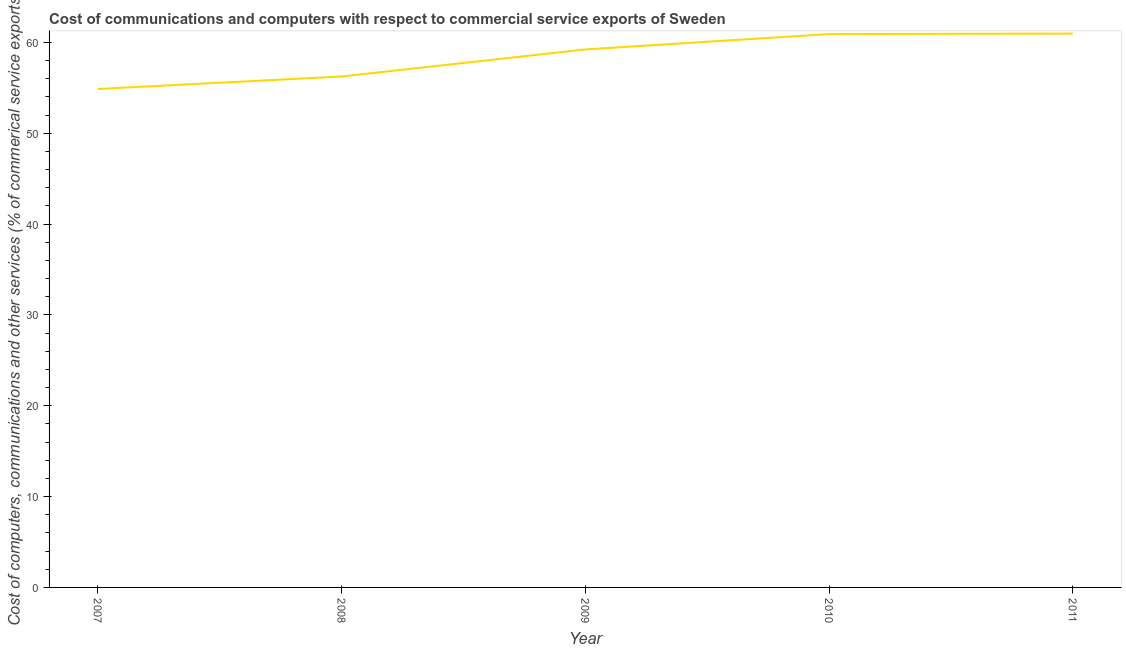What is the  computer and other services in 2010?
Give a very brief answer. 60.91. Across all years, what is the maximum cost of communications?
Provide a short and direct response. 60.97. Across all years, what is the minimum cost of communications?
Provide a short and direct response. 54.87. What is the sum of the  computer and other services?
Make the answer very short. 292.21. What is the difference between the  computer and other services in 2007 and 2011?
Make the answer very short. -6.1. What is the average cost of communications per year?
Your response must be concise. 58.44. What is the median  computer and other services?
Offer a terse response. 59.22. In how many years, is the cost of communications greater than 8 %?
Keep it short and to the point. 5. Do a majority of the years between 2007 and 2008 (inclusive) have cost of communications greater than 52 %?
Provide a short and direct response. Yes. What is the ratio of the  computer and other services in 2010 to that in 2011?
Offer a terse response. 1. What is the difference between the highest and the second highest  computer and other services?
Give a very brief answer. 0.05. What is the difference between the highest and the lowest  computer and other services?
Offer a terse response. 6.1. In how many years, is the  computer and other services greater than the average  computer and other services taken over all years?
Make the answer very short. 3. How many lines are there?
Offer a very short reply. 1. Does the graph contain grids?
Ensure brevity in your answer.  No. What is the title of the graph?
Make the answer very short. Cost of communications and computers with respect to commercial service exports of Sweden. What is the label or title of the X-axis?
Offer a terse response. Year. What is the label or title of the Y-axis?
Keep it short and to the point. Cost of computers, communications and other services (% of commerical service exports). What is the Cost of computers, communications and other services (% of commerical service exports) in 2007?
Give a very brief answer. 54.87. What is the Cost of computers, communications and other services (% of commerical service exports) in 2008?
Ensure brevity in your answer.  56.24. What is the Cost of computers, communications and other services (% of commerical service exports) in 2009?
Offer a very short reply. 59.22. What is the Cost of computers, communications and other services (% of commerical service exports) of 2010?
Your response must be concise. 60.91. What is the Cost of computers, communications and other services (% of commerical service exports) in 2011?
Ensure brevity in your answer.  60.97. What is the difference between the Cost of computers, communications and other services (% of commerical service exports) in 2007 and 2008?
Give a very brief answer. -1.38. What is the difference between the Cost of computers, communications and other services (% of commerical service exports) in 2007 and 2009?
Keep it short and to the point. -4.35. What is the difference between the Cost of computers, communications and other services (% of commerical service exports) in 2007 and 2010?
Keep it short and to the point. -6.04. What is the difference between the Cost of computers, communications and other services (% of commerical service exports) in 2007 and 2011?
Make the answer very short. -6.1. What is the difference between the Cost of computers, communications and other services (% of commerical service exports) in 2008 and 2009?
Your response must be concise. -2.98. What is the difference between the Cost of computers, communications and other services (% of commerical service exports) in 2008 and 2010?
Your answer should be compact. -4.67. What is the difference between the Cost of computers, communications and other services (% of commerical service exports) in 2008 and 2011?
Keep it short and to the point. -4.72. What is the difference between the Cost of computers, communications and other services (% of commerical service exports) in 2009 and 2010?
Make the answer very short. -1.69. What is the difference between the Cost of computers, communications and other services (% of commerical service exports) in 2009 and 2011?
Ensure brevity in your answer.  -1.74. What is the difference between the Cost of computers, communications and other services (% of commerical service exports) in 2010 and 2011?
Keep it short and to the point. -0.05. What is the ratio of the Cost of computers, communications and other services (% of commerical service exports) in 2007 to that in 2008?
Make the answer very short. 0.98. What is the ratio of the Cost of computers, communications and other services (% of commerical service exports) in 2007 to that in 2009?
Offer a terse response. 0.93. What is the ratio of the Cost of computers, communications and other services (% of commerical service exports) in 2007 to that in 2010?
Give a very brief answer. 0.9. What is the ratio of the Cost of computers, communications and other services (% of commerical service exports) in 2007 to that in 2011?
Provide a succinct answer. 0.9. What is the ratio of the Cost of computers, communications and other services (% of commerical service exports) in 2008 to that in 2009?
Ensure brevity in your answer.  0.95. What is the ratio of the Cost of computers, communications and other services (% of commerical service exports) in 2008 to that in 2010?
Your answer should be compact. 0.92. What is the ratio of the Cost of computers, communications and other services (% of commerical service exports) in 2008 to that in 2011?
Give a very brief answer. 0.92. What is the ratio of the Cost of computers, communications and other services (% of commerical service exports) in 2009 to that in 2011?
Offer a terse response. 0.97. 